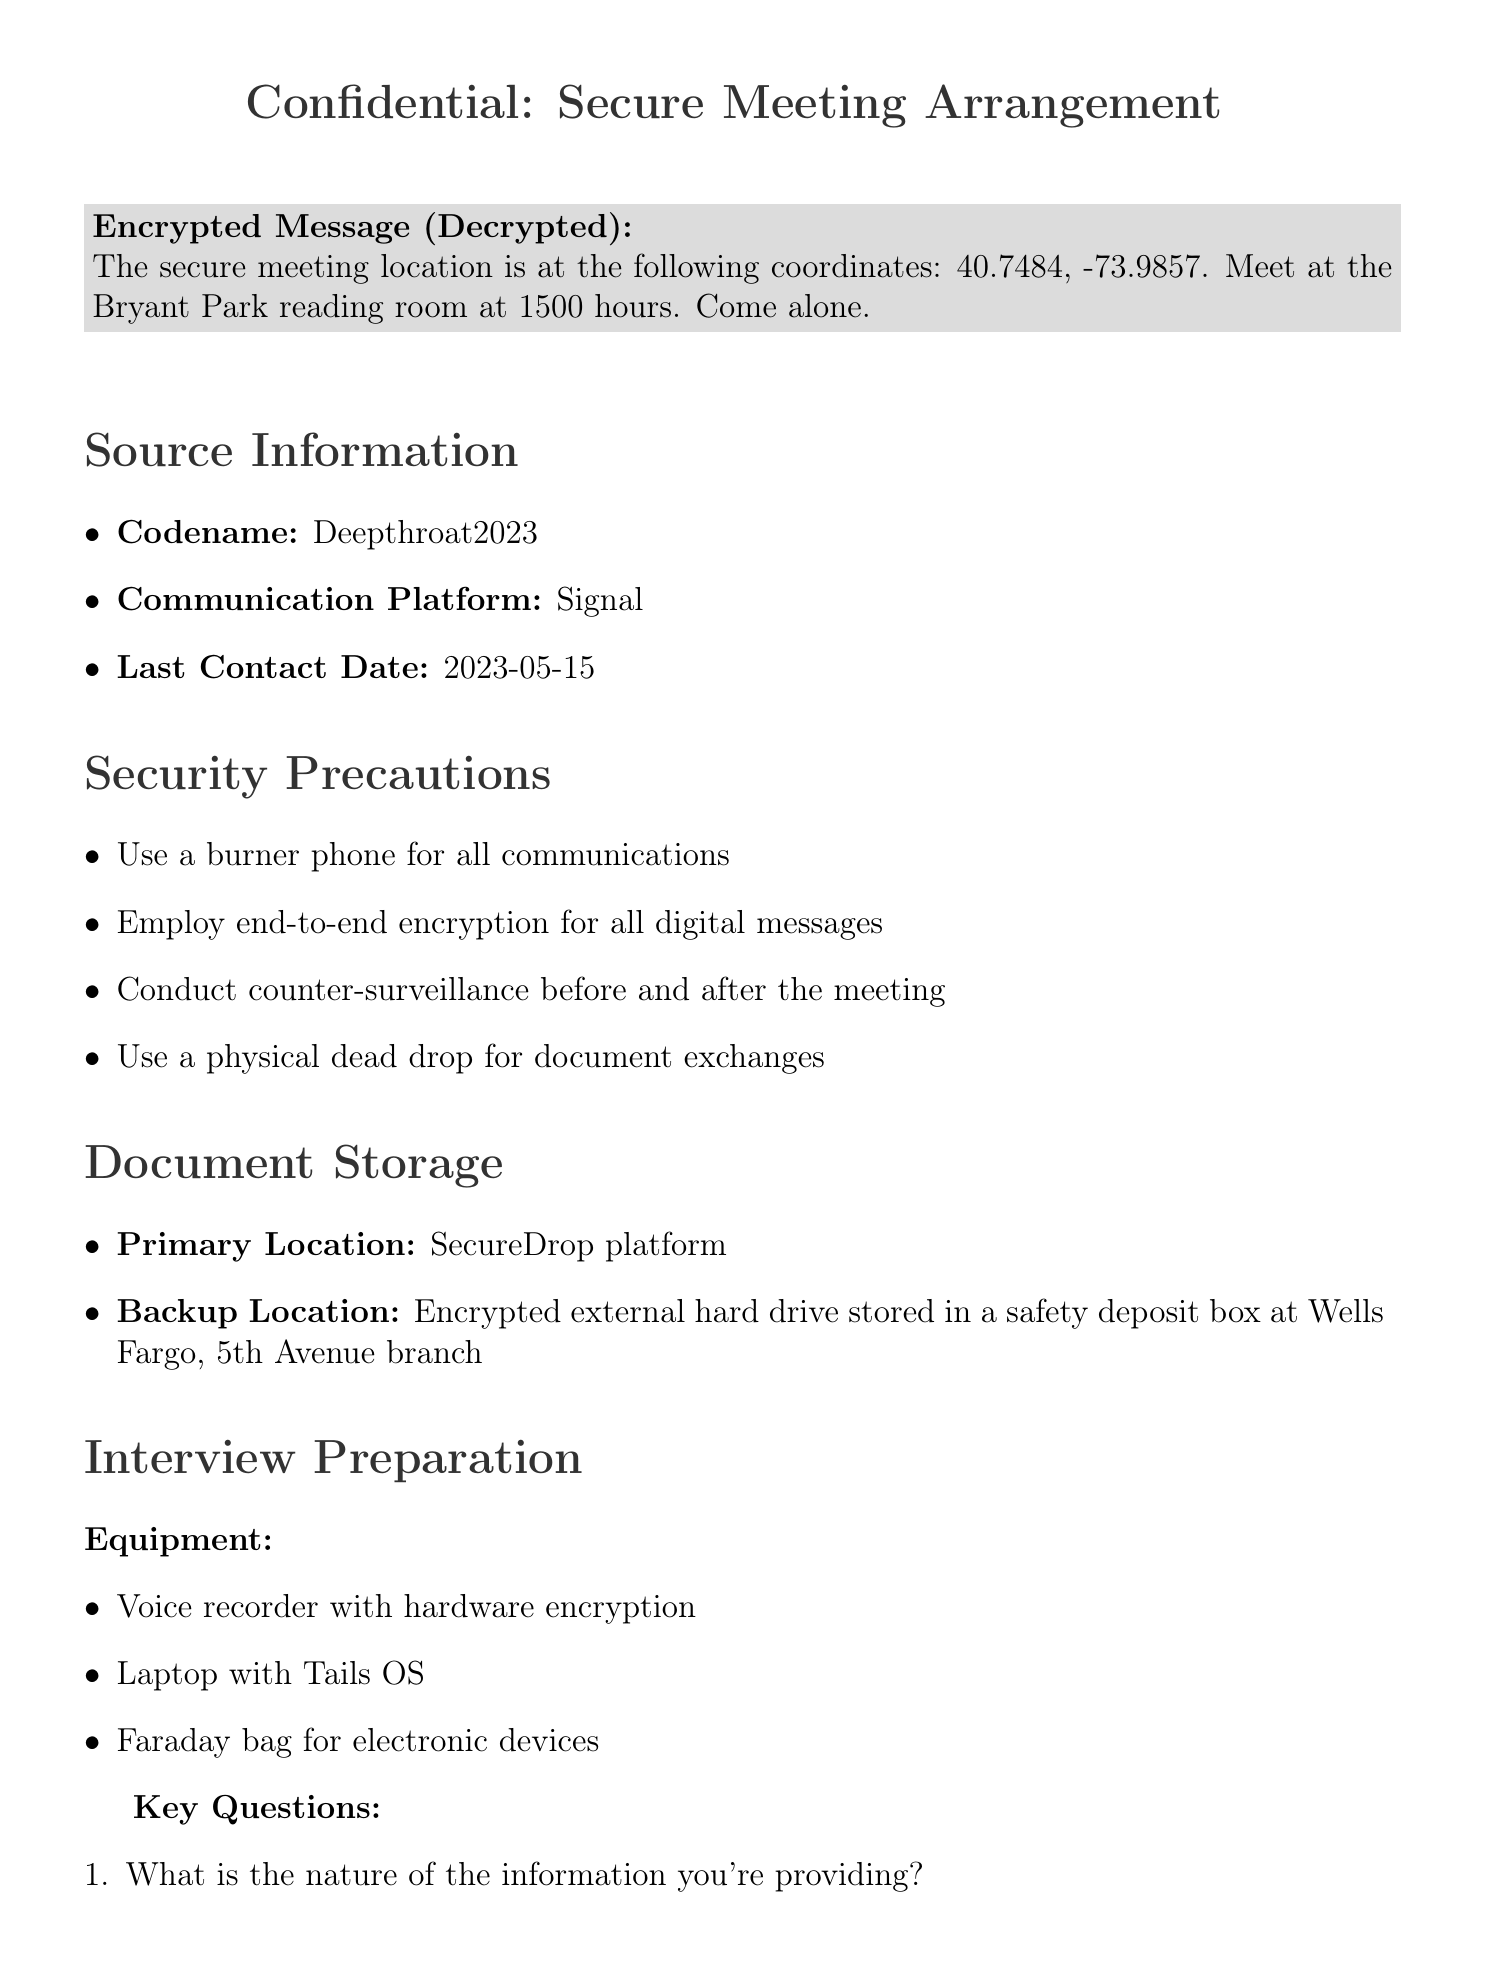What are the coordinates for the secure meeting location? The coordinates are explicitly mentioned in the decrypted content of the document.
Answer: 40.7484, -73.9857 What is the name of the location where the meeting will be held? The location is stated in the decrypted content of the document as the specific venue for the meeting.
Answer: Bryant Park reading room What time is the meeting scheduled for? The time is included in the decrypted content of the document, specifying when to meet.
Answer: 1500 hours What is the codename of the source? The document lists the source’s codename in the source information section.
Answer: Deepthroat2023 What communication platform should be used for discussions? The document states the communication method recommended for interactions with the source.
Answer: Signal Who is the attorney mentioned in the document? The document specifies the name of the attorney in the legal considerations section.
Answer: Gloria Allred What type of urgency is suggested for conducting counter-surveillance? The need for counter-surveillance is included in the security precautions, which highlights the importance of safety.
Answer: Before and after the meeting What is the primary location for document storage? The document mentions where the documents should be securely stored in the document storage section.
Answer: SecureDrop platform What is the editorial approval process outlined in the document? The document specifies a detailed process for editorial approval before publication, ensuring thorough checks.
Answer: Three-tier fact-checking and legal review before publication 